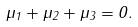Convert formula to latex. <formula><loc_0><loc_0><loc_500><loc_500>\mu _ { 1 } + \mu _ { 2 } + \mu _ { 3 } = 0 .</formula> 